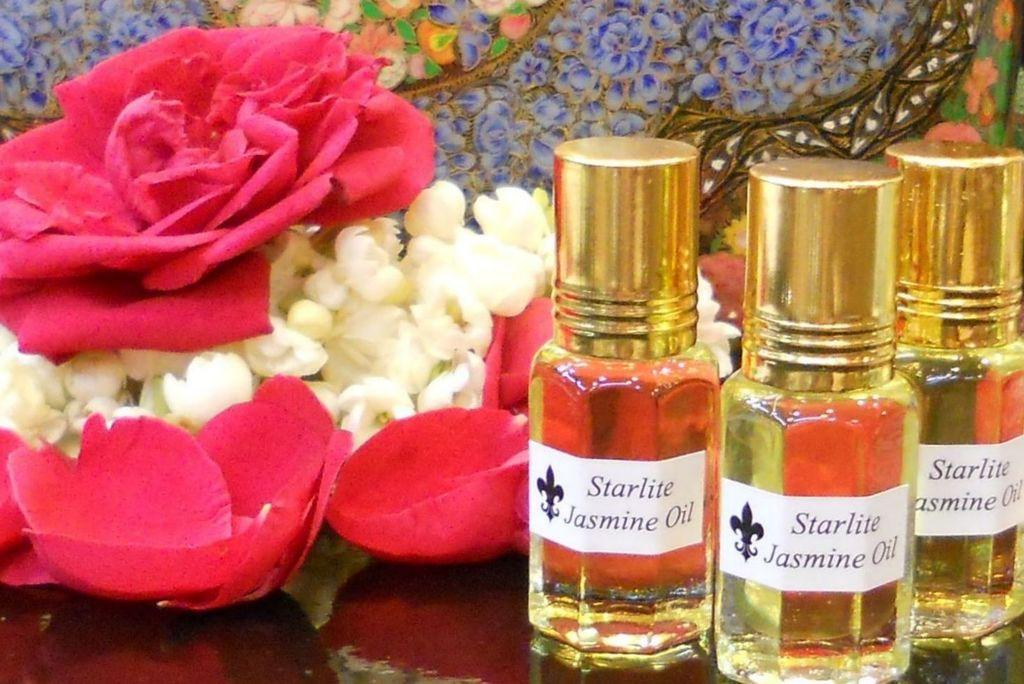Provide a one-sentence caption for the provided image. some three colognes with starlite written on them. 